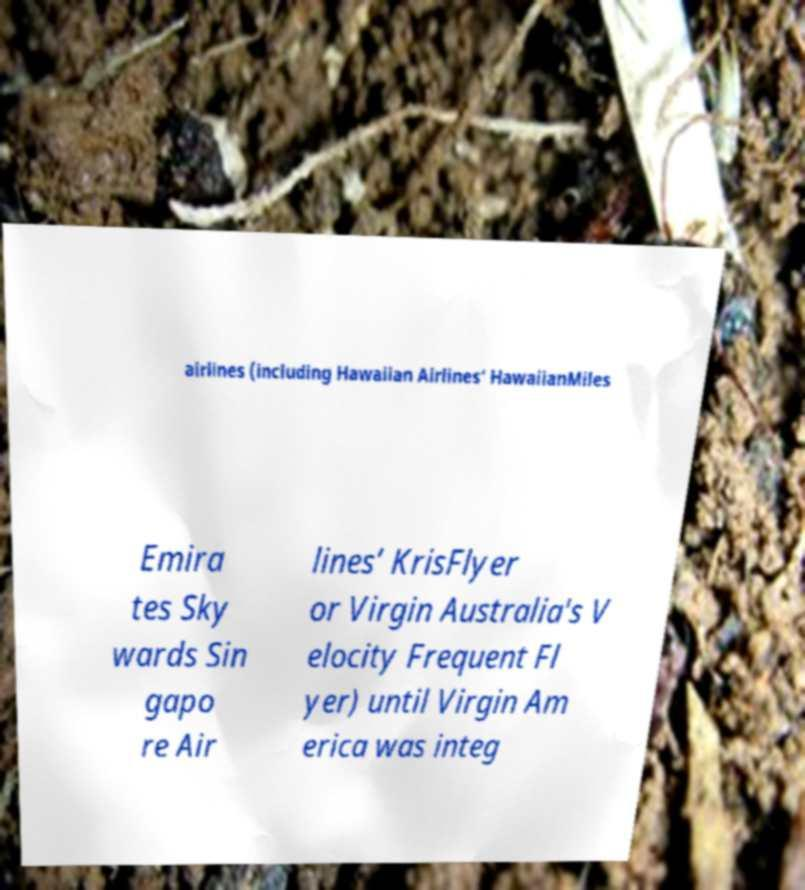Can you accurately transcribe the text from the provided image for me? airlines (including Hawaiian Airlines‘ HawaiianMiles Emira tes Sky wards Sin gapo re Air lines’ KrisFlyer or Virgin Australia's V elocity Frequent Fl yer) until Virgin Am erica was integ 